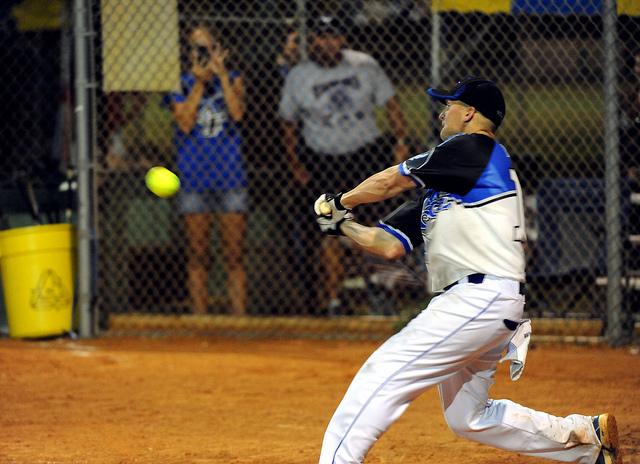Can you see the ball?
Concise answer only. Yes. What team is this baseball uniform for?
Quick response, please. Blue. What are the kids doing?
Short answer required. Playing baseball. What sport is this?
Write a very short answer. Baseball. Is the ball coming towards him?
Keep it brief. Yes. IS this man playing baseball?
Keep it brief. Yes. Is the batter wearing a helmet?
Be succinct. No. 